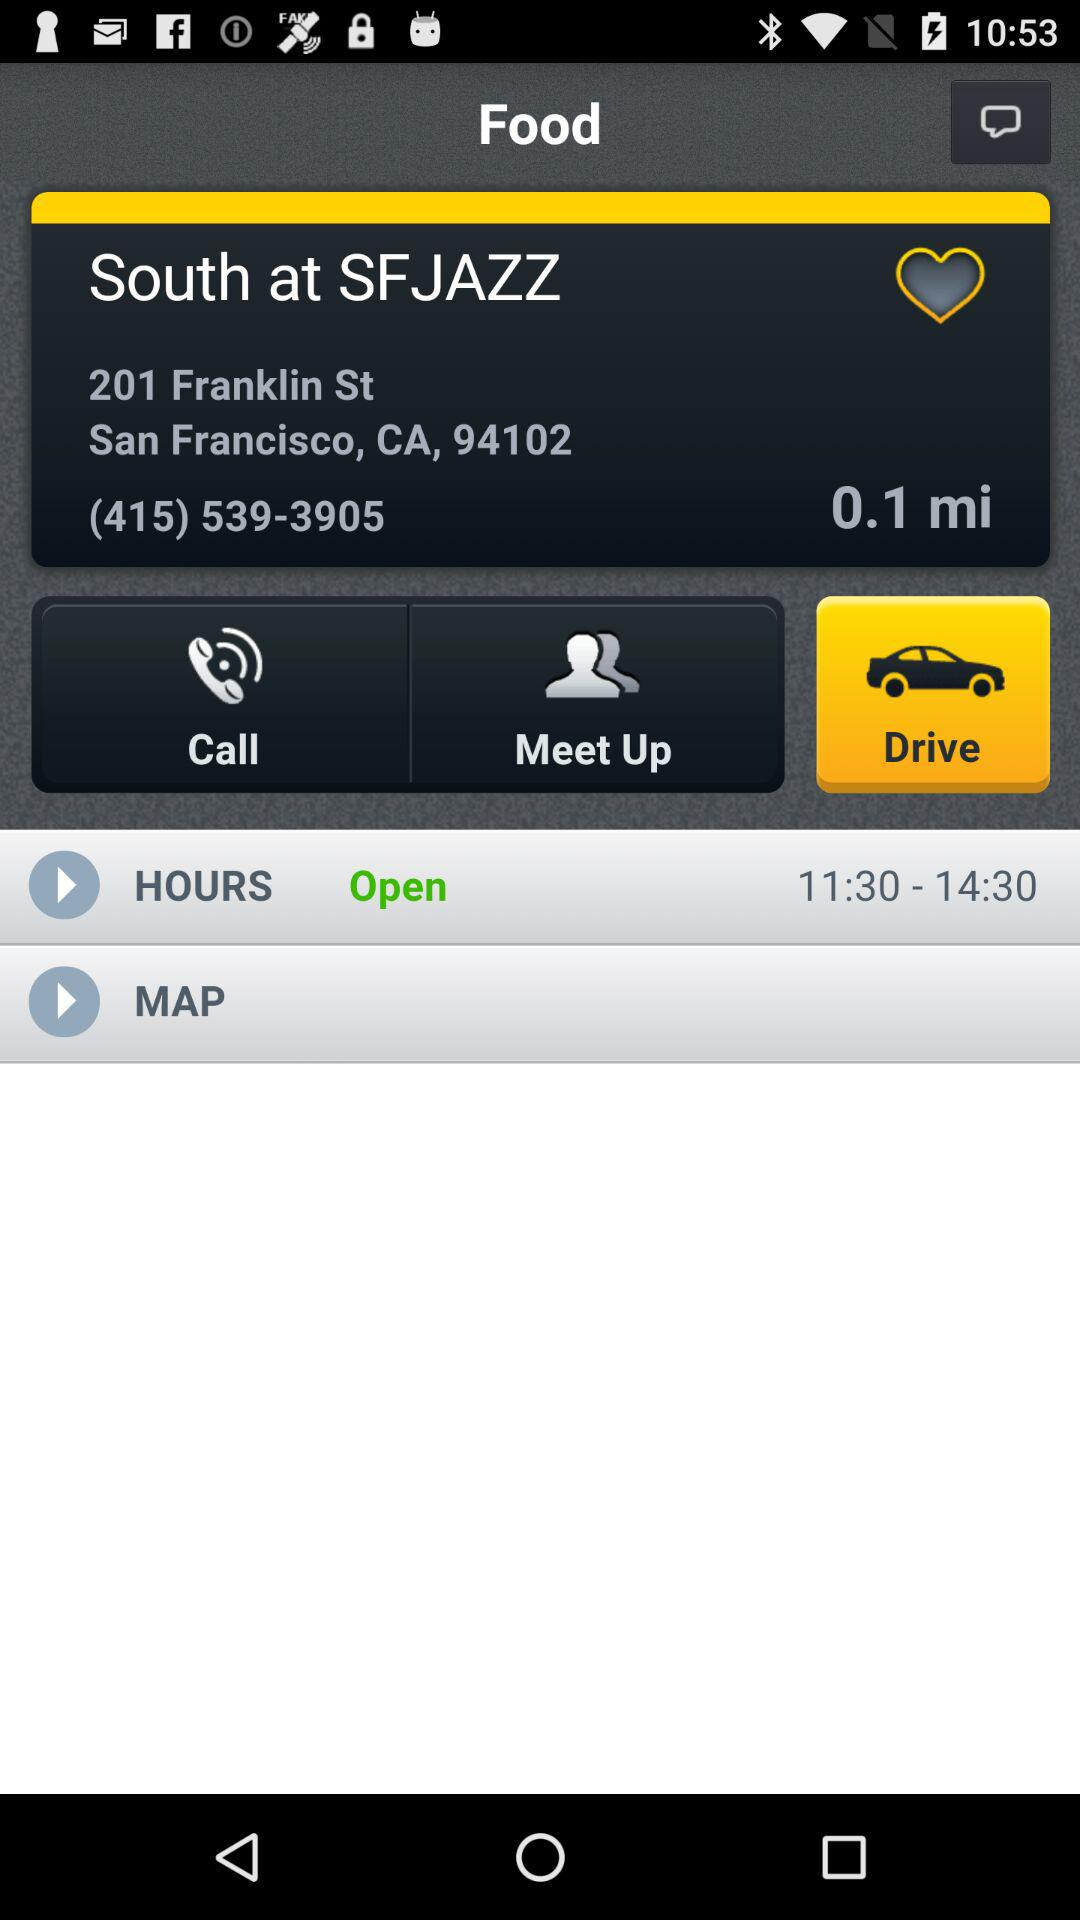What mode is selected? The selected mode is "Drive". 